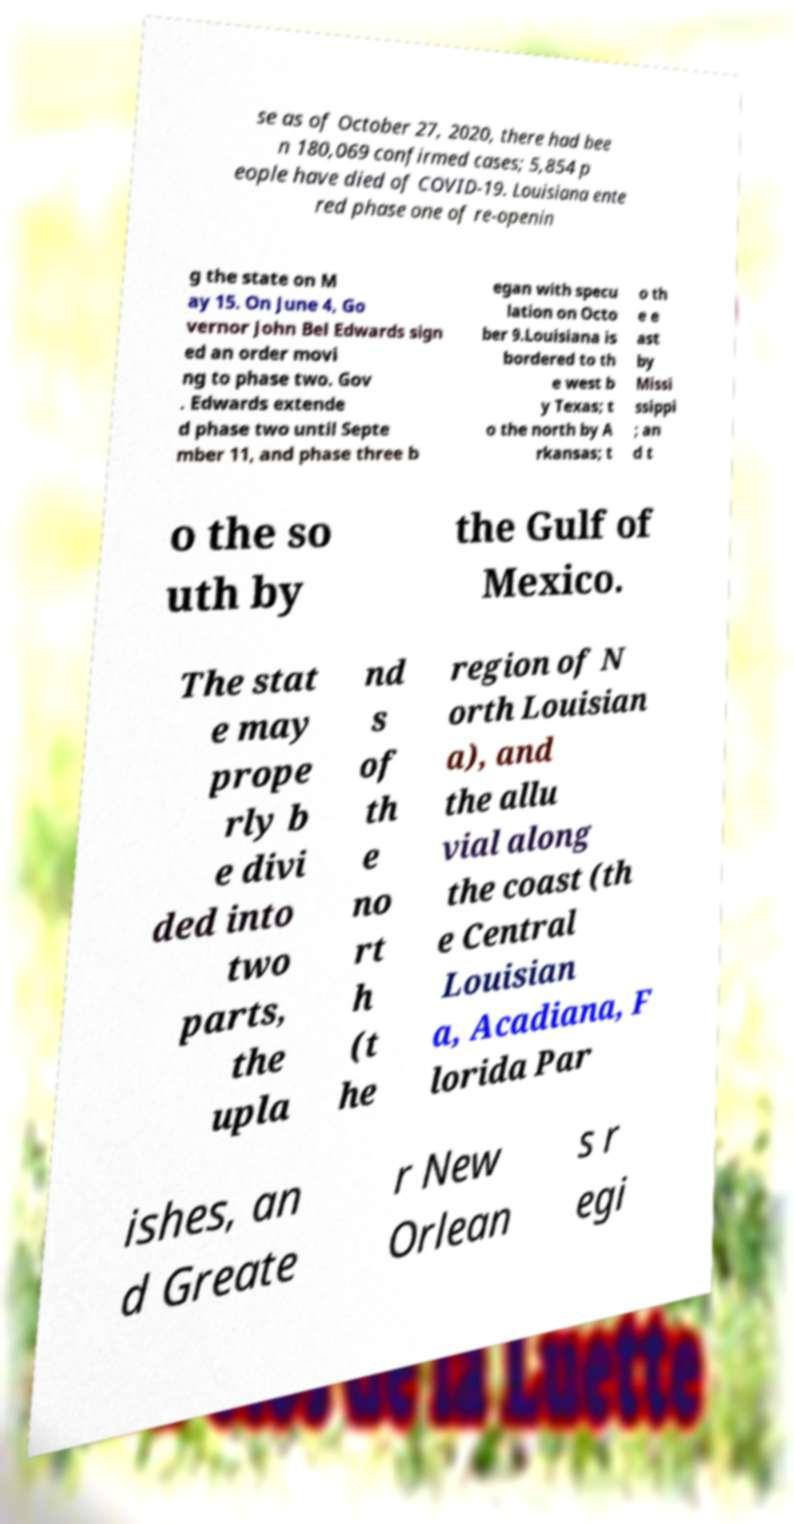Can you read and provide the text displayed in the image?This photo seems to have some interesting text. Can you extract and type it out for me? se as of October 27, 2020, there had bee n 180,069 confirmed cases; 5,854 p eople have died of COVID-19. Louisiana ente red phase one of re-openin g the state on M ay 15. On June 4, Go vernor John Bel Edwards sign ed an order movi ng to phase two. Gov . Edwards extende d phase two until Septe mber 11, and phase three b egan with specu lation on Octo ber 9.Louisiana is bordered to th e west b y Texas; t o the north by A rkansas; t o th e e ast by Missi ssippi ; an d t o the so uth by the Gulf of Mexico. The stat e may prope rly b e divi ded into two parts, the upla nd s of th e no rt h (t he region of N orth Louisian a), and the allu vial along the coast (th e Central Louisian a, Acadiana, F lorida Par ishes, an d Greate r New Orlean s r egi 